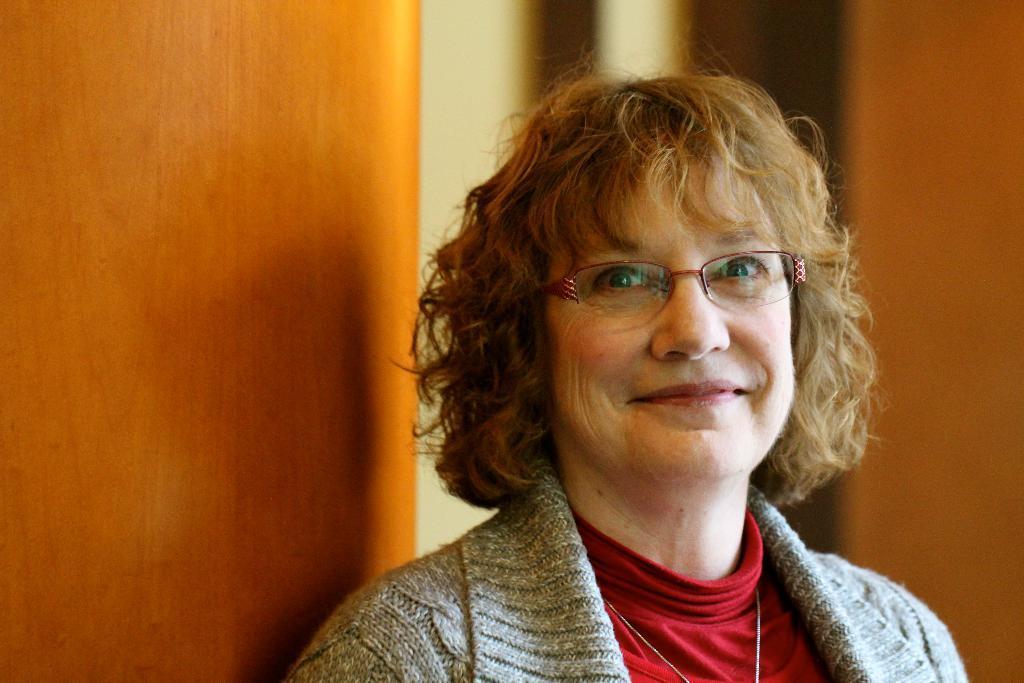Can you describe this image briefly? In this picture I can see a woman she wore spectacles on her face and she wore a coat and I can see a door on the left side. 